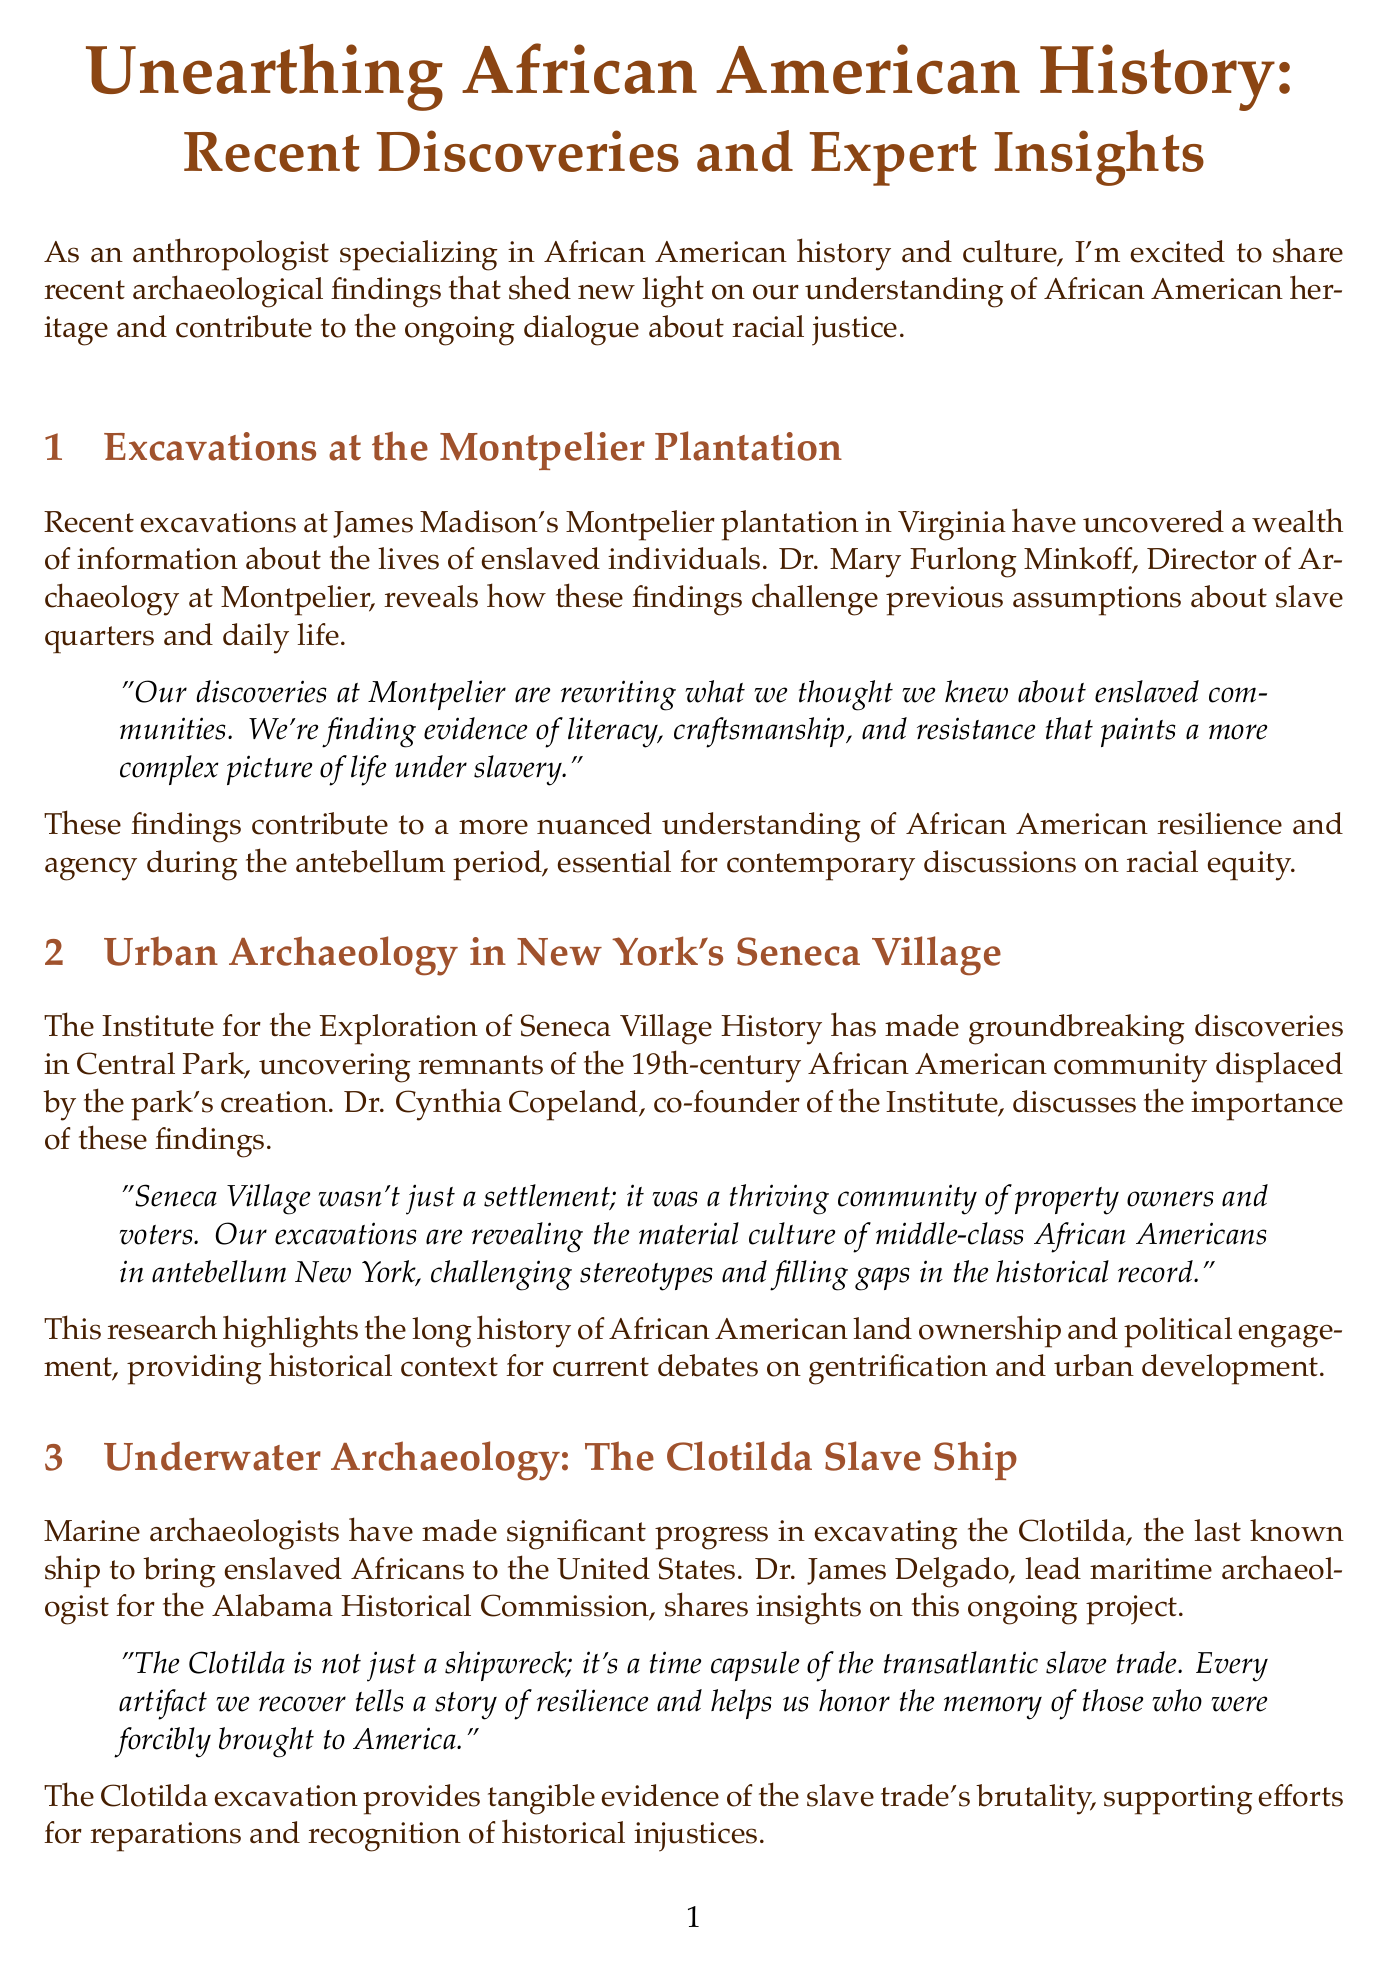What is the title of the newsletter? The title of the newsletter is mentioned at the beginning of the document.
Answer: Unearthing African American History: Recent Discoveries and Expert Insights Who is the Director of Archaeology at Montpelier? The document provides the name and title of a key figure in the excavation at Montpelier.
Answer: Dr. Mary Furlong Minkoff What artifact is being excavated at the Clotilda? The document specifies the focus of the underwater archaeology project.
Answer: The Clotilda How many experts are featured in the panel section? The document lists the number of individuals contributing insights in the expert panel section.
Answer: Two What was Seneca Village? The content describes the significance of the community that was uncovered in New York City.
Answer: A thriving community of property owners and voters What is the main focus of the community engagement section? The document outlines the approach of involving local communities in archaeology.
Answer: Connecting with their heritage What does Dr. Whitney Battle-Baptiste mention about archaeology? The document quotes her on the impact of archaeology on understanding historical contributions.
Answer: Concrete evidence of African American contributions What does the Montpelier Descendants Committee represent? This organization plays a vital role in the excavation project mentioned in the document.
Answer: Descendants of the plantation's enslaved community 